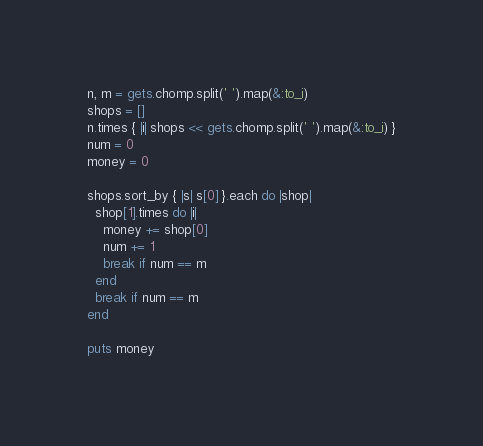<code> <loc_0><loc_0><loc_500><loc_500><_Ruby_>n, m = gets.chomp.split(' ').map(&:to_i)
shops = []
n.times { |i| shops << gets.chomp.split(' ').map(&:to_i) }
num = 0
money = 0

shops.sort_by { |s| s[0] }.each do |shop|
  shop[1].times do |i|
    money += shop[0]
    num += 1
    break if num == m
  end
  break if num == m
end

puts money</code> 